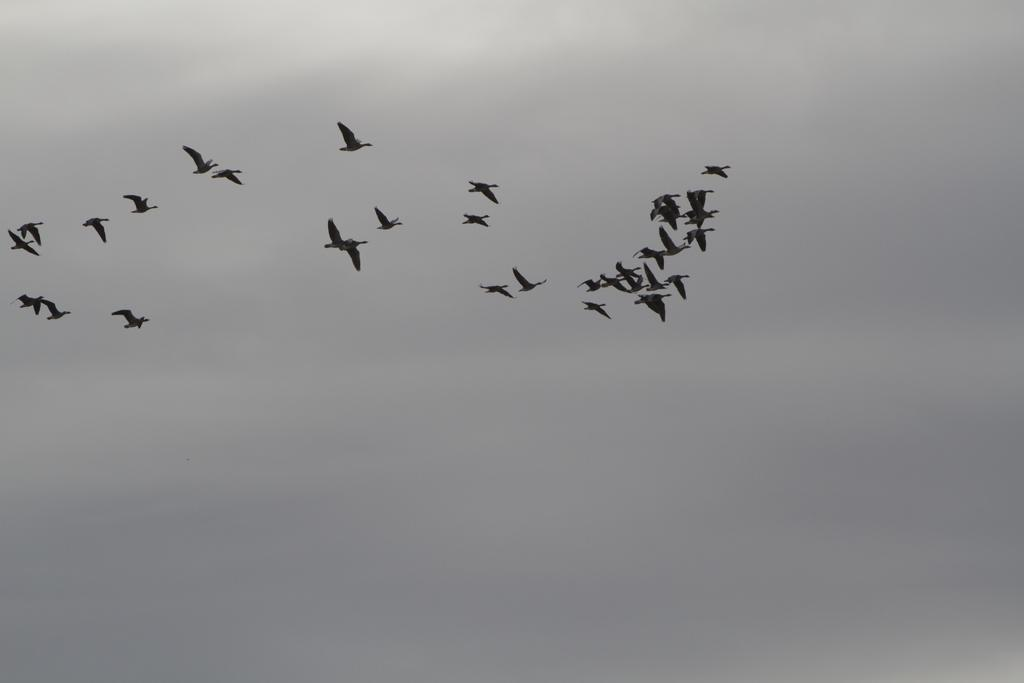What type of birds can be seen in the image? There are black colored birds in the image. What are the birds doing in the image? The birds are flying in the air. What is visible at the top of the image? The sky is visible at the top of the image. What is the condition of the sky in the image? The sky is cloudy in the image. Where is the hydrant located in the image? There is no hydrant present in the image. What are the children doing in the image? There are no children present in the image. 